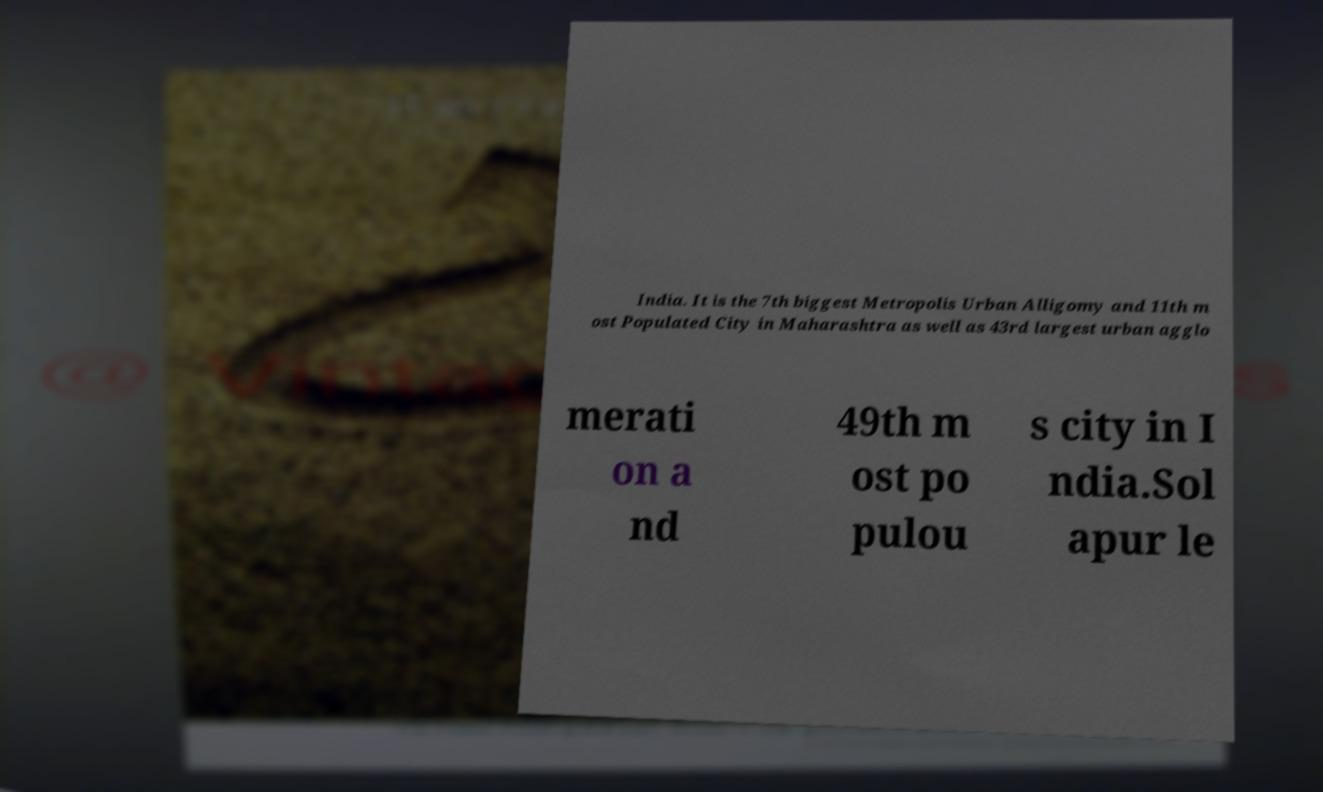Can you accurately transcribe the text from the provided image for me? India. It is the 7th biggest Metropolis Urban Alligomy and 11th m ost Populated City in Maharashtra as well as 43rd largest urban agglo merati on a nd 49th m ost po pulou s city in I ndia.Sol apur le 